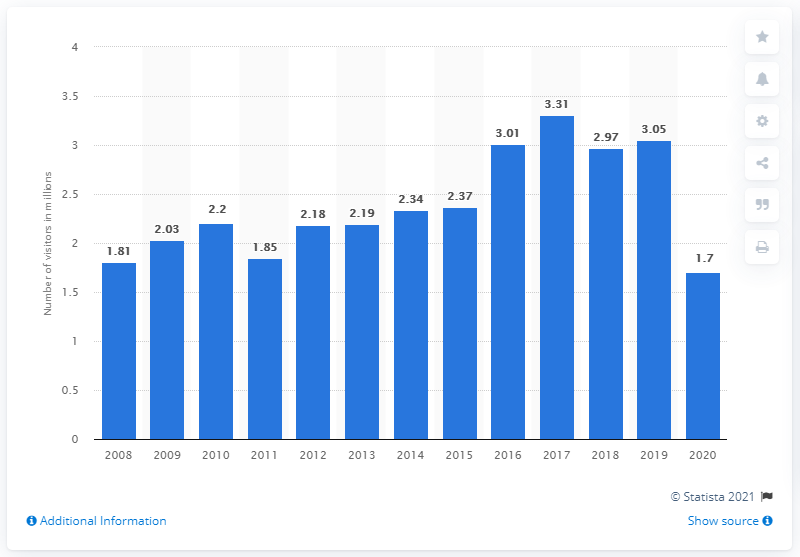Indicate a few pertinent items in this graphic. In 2019, Glacier National Park had a visitation value of 3.05. In 2019, Glacier National Park's visitation value was 3.05 million. 